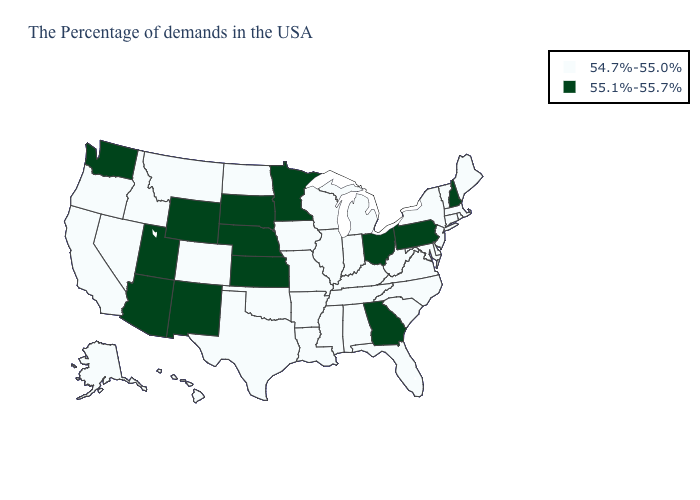Which states have the lowest value in the USA?
Write a very short answer. Maine, Massachusetts, Rhode Island, Vermont, Connecticut, New York, New Jersey, Delaware, Maryland, Virginia, North Carolina, South Carolina, West Virginia, Florida, Michigan, Kentucky, Indiana, Alabama, Tennessee, Wisconsin, Illinois, Mississippi, Louisiana, Missouri, Arkansas, Iowa, Oklahoma, Texas, North Dakota, Colorado, Montana, Idaho, Nevada, California, Oregon, Alaska, Hawaii. What is the highest value in states that border South Carolina?
Short answer required. 55.1%-55.7%. What is the value of Ohio?
Write a very short answer. 55.1%-55.7%. Does Virginia have a lower value than Alabama?
Short answer required. No. Does Minnesota have a higher value than Nebraska?
Short answer required. No. What is the value of West Virginia?
Keep it brief. 54.7%-55.0%. What is the highest value in the USA?
Short answer required. 55.1%-55.7%. What is the value of Kentucky?
Give a very brief answer. 54.7%-55.0%. What is the lowest value in states that border Tennessee?
Quick response, please. 54.7%-55.0%. What is the lowest value in states that border New Hampshire?
Quick response, please. 54.7%-55.0%. Name the states that have a value in the range 55.1%-55.7%?
Short answer required. New Hampshire, Pennsylvania, Ohio, Georgia, Minnesota, Kansas, Nebraska, South Dakota, Wyoming, New Mexico, Utah, Arizona, Washington. Does Kentucky have the highest value in the USA?
Short answer required. No. Does Delaware have the lowest value in the South?
Concise answer only. Yes. What is the value of Alabama?
Quick response, please. 54.7%-55.0%. Is the legend a continuous bar?
Quick response, please. No. 